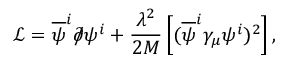<formula> <loc_0><loc_0><loc_500><loc_500>\mathcal { L } = \overline { \psi } ^ { i } \partial \, \slash \psi ^ { i } + \frac { \lambda ^ { 2 } } { 2 M } \left [ ( \overline { \psi } ^ { i } \gamma _ { \mu } \psi ^ { i } ) ^ { 2 } \right ] ,</formula> 